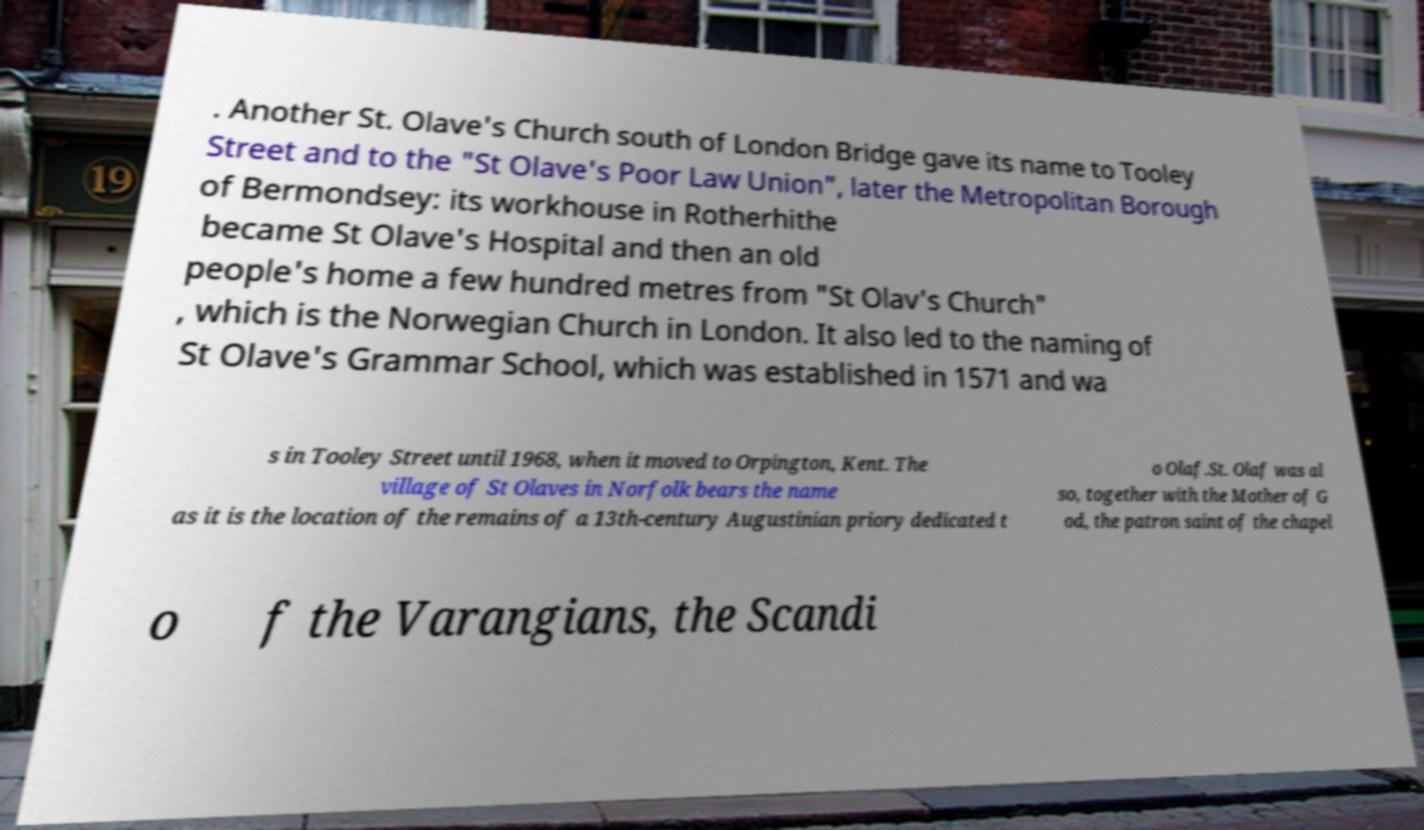Could you assist in decoding the text presented in this image and type it out clearly? . Another St. Olave's Church south of London Bridge gave its name to Tooley Street and to the "St Olave's Poor Law Union", later the Metropolitan Borough of Bermondsey: its workhouse in Rotherhithe became St Olave's Hospital and then an old people's home a few hundred metres from "St Olav's Church" , which is the Norwegian Church in London. It also led to the naming of St Olave's Grammar School, which was established in 1571 and wa s in Tooley Street until 1968, when it moved to Orpington, Kent. The village of St Olaves in Norfolk bears the name as it is the location of the remains of a 13th-century Augustinian priory dedicated t o Olaf.St. Olaf was al so, together with the Mother of G od, the patron saint of the chapel o f the Varangians, the Scandi 